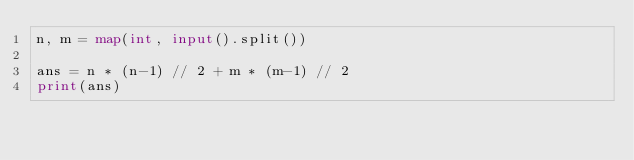Convert code to text. <code><loc_0><loc_0><loc_500><loc_500><_Python_>n, m = map(int, input().split())

ans = n * (n-1) // 2 + m * (m-1) // 2
print(ans)</code> 